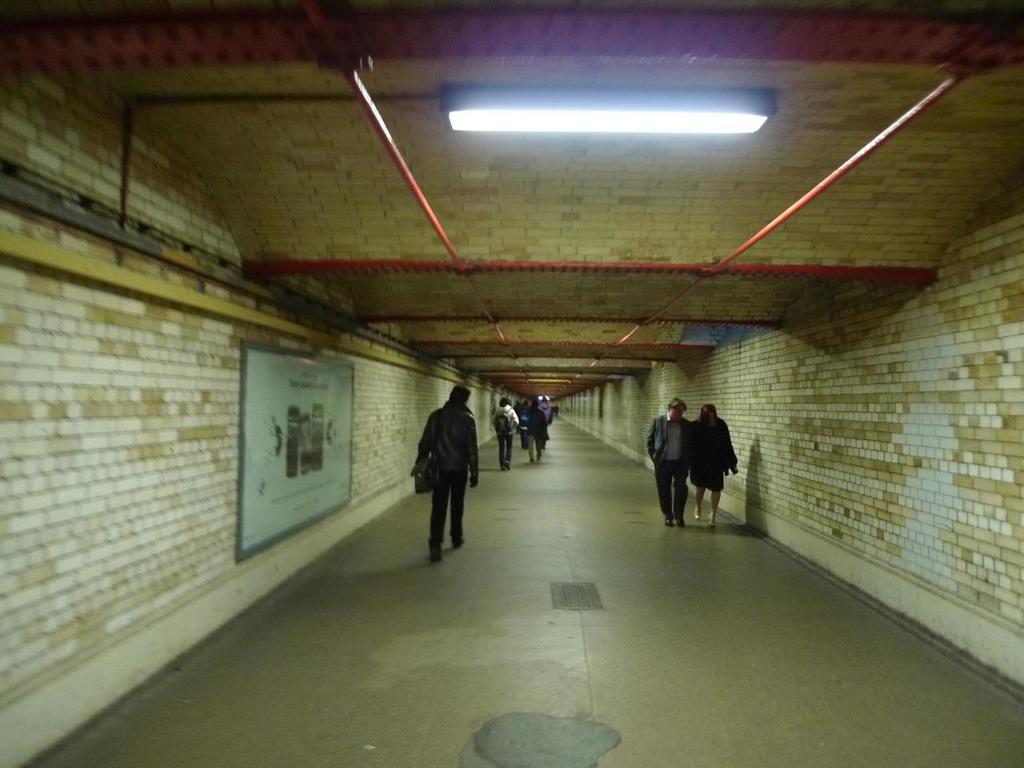Where was the image taken? The image was taken in a subway. What are the people in the image doing? There is a group of people walking in the image. What can be seen on the left wall of the subway? There is a poster with images and text on the left wall. What provides illumination in the subway? There are lights on the roof of the subway. Are there any fairies visible in the image? No, there are no fairies present in the image. What type of curve can be seen in the subway? There is no curve visible in the image; it is a straight subway tunnel. 